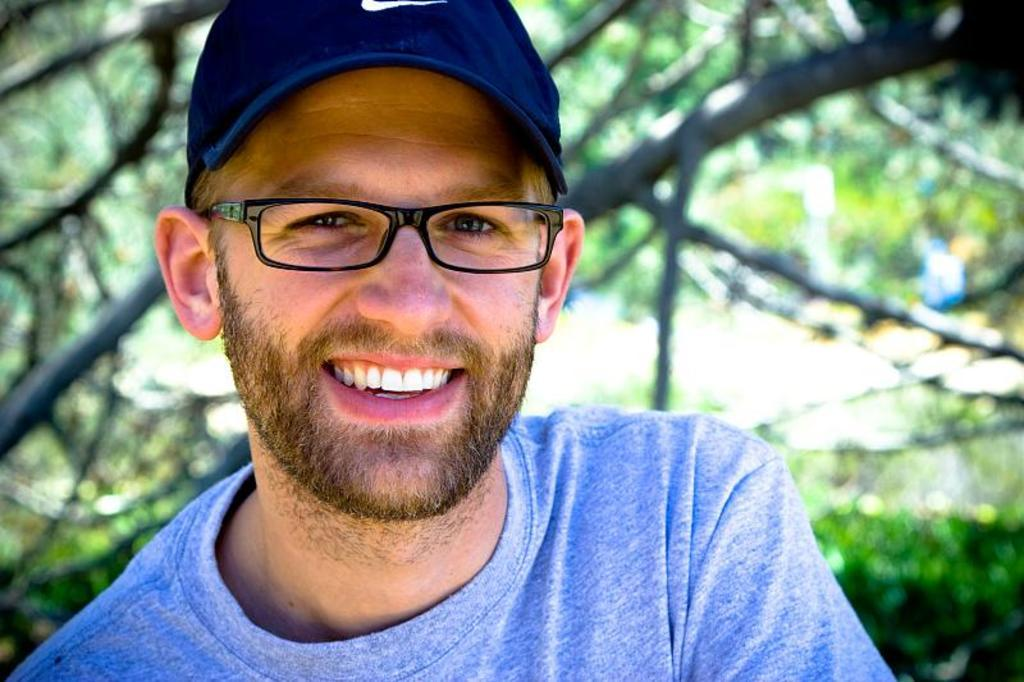What is the main subject of the image? There is a person in the image. What is the person wearing on their upper body? The person is wearing a blue T-shirt. What type of headwear is the person wearing? The person is wearing a cap. What type of eyewear is the person wearing? The person is wearing black color spectacles. What is the facial expression of the person? The person is smiling. How would you describe the background of the image? The background of the image is blurry. How many books can be seen on the shelf behind the person in the image? There is no shelf or books visible in the image; it only features a person with a blurry background. 